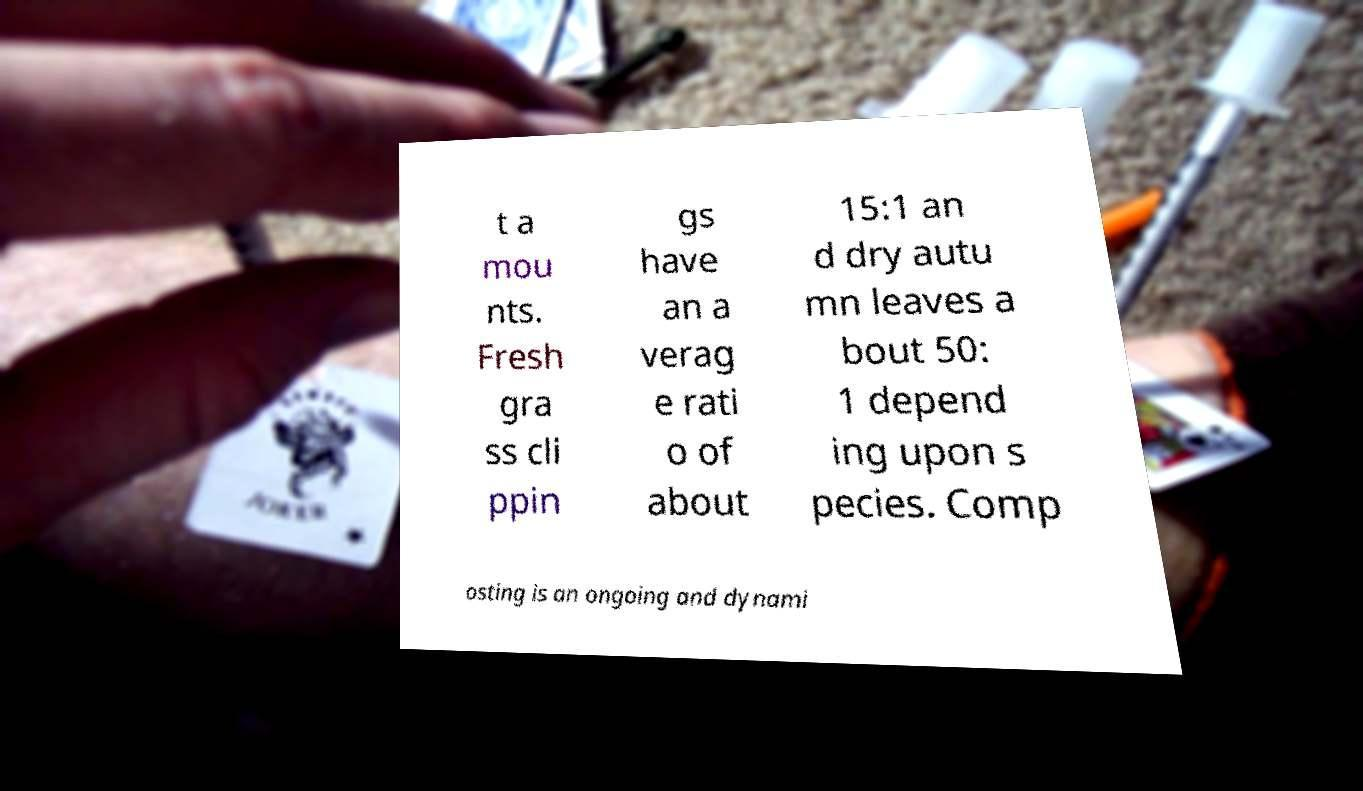There's text embedded in this image that I need extracted. Can you transcribe it verbatim? t a mou nts. Fresh gra ss cli ppin gs have an a verag e rati o of about 15:1 an d dry autu mn leaves a bout 50: 1 depend ing upon s pecies. Comp osting is an ongoing and dynami 